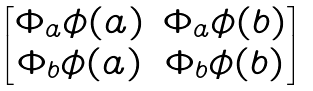Convert formula to latex. <formula><loc_0><loc_0><loc_500><loc_500>\begin{bmatrix} \Phi _ { a } \phi ( a ) & \Phi _ { a } \phi ( b ) \\ \Phi _ { b } \phi ( a ) & \Phi _ { b } \phi ( b ) \end{bmatrix}</formula> 